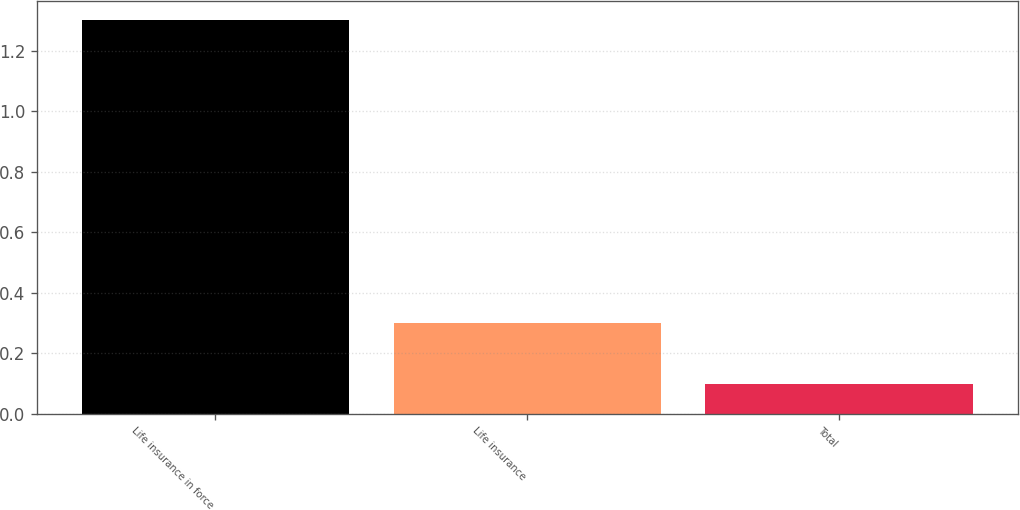Convert chart to OTSL. <chart><loc_0><loc_0><loc_500><loc_500><bar_chart><fcel>Life insurance in force<fcel>Life insurance<fcel>Total<nl><fcel>1.3<fcel>0.3<fcel>0.1<nl></chart> 